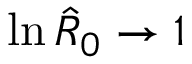<formula> <loc_0><loc_0><loc_500><loc_500>\ln { \hat { R } _ { 0 } } \to 1</formula> 